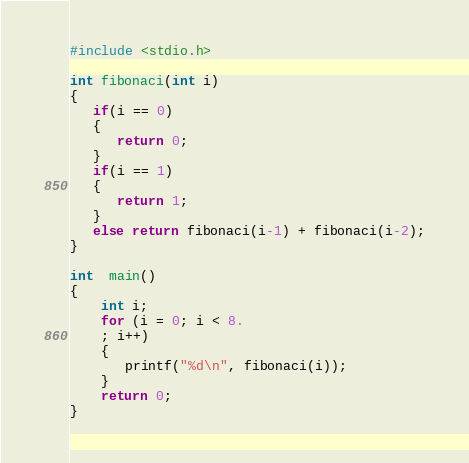Convert code to text. <code><loc_0><loc_0><loc_500><loc_500><_C_>#include <stdio.h>

int fibonaci(int i)
{
   if(i == 0)
   {
      return 0;
   }
   if(i == 1)
   {
      return 1;
   }
   else return fibonaci(i-1) + fibonaci(i-2);
}

int  main()
{
    int i;
    for (i = 0; i < 8.
    ; i++)
    {
       printf("%d\n", fibonaci(i));
    }
    return 0;
}
</code> 